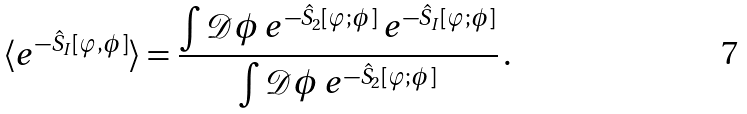Convert formula to latex. <formula><loc_0><loc_0><loc_500><loc_500>\langle e ^ { - \hat { S } _ { I } [ \varphi , \phi ] } \rangle = \frac { \int \mathcal { D } \phi \, e ^ { - \hat { S } _ { 2 } [ \varphi ; \phi ] } \, e ^ { - \hat { S } _ { I } [ \varphi ; \phi ] } } { \int \mathcal { D } \phi \, e ^ { - \hat { S } _ { 2 } [ \varphi ; \phi ] } } \, .</formula> 